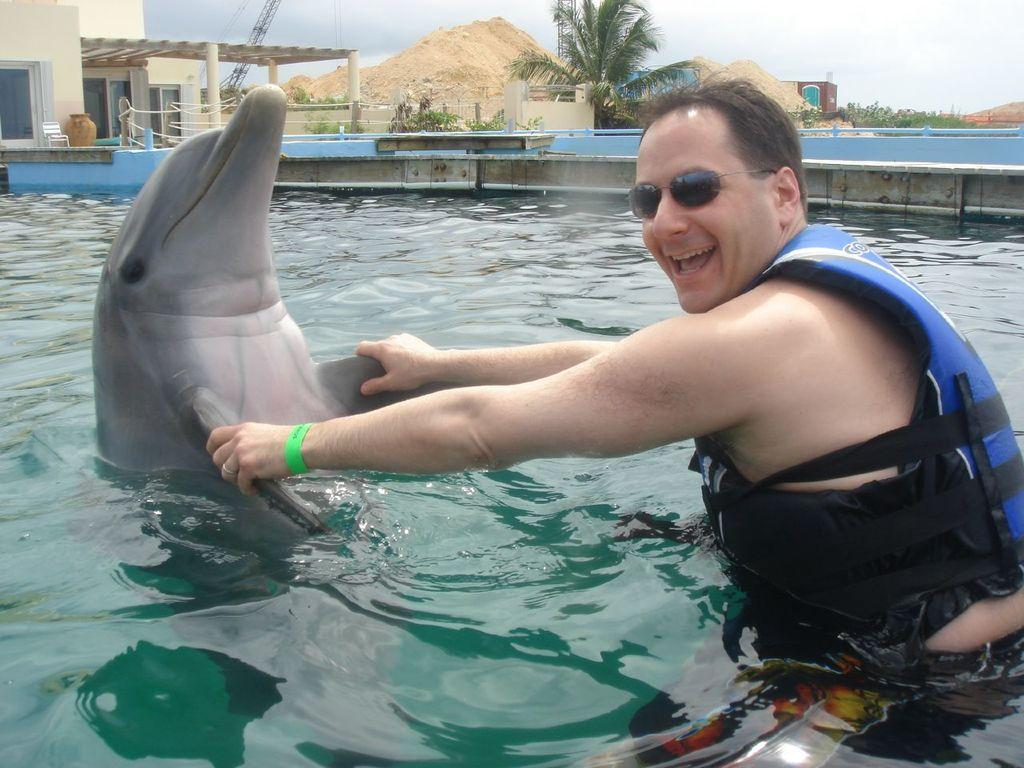What is happening in the image? There is a person in the image playing with a dolphin in a swimming pool. What can be seen in the background of the image? Buildings and trees are visible in the background of the image. What is the weather like in the image? The background is cloudy in the image. What type of insurance does the person have for the dolphin in the image? There is no information about insurance in the image, as it focuses on the person playing with a dolphin in a swimming pool. 